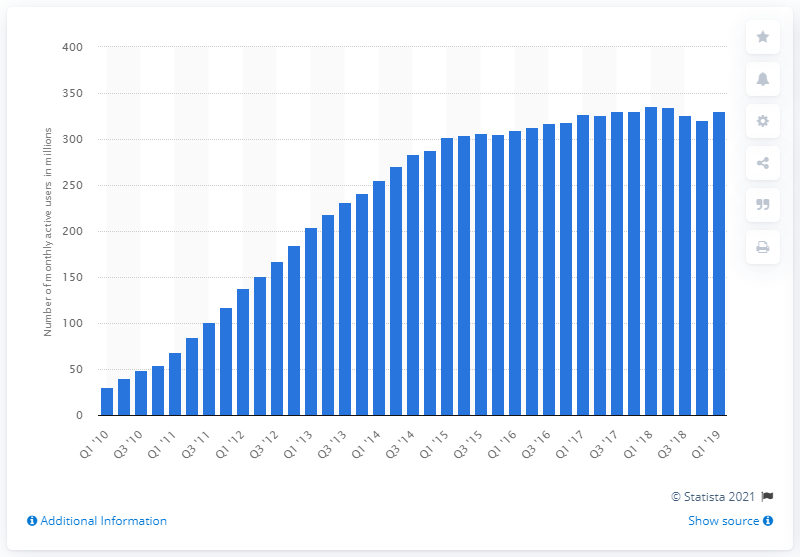Highlight a few significant elements in this photo. As of the first quarter of 2019, Twitter had approximately 330 million monthly active users. 